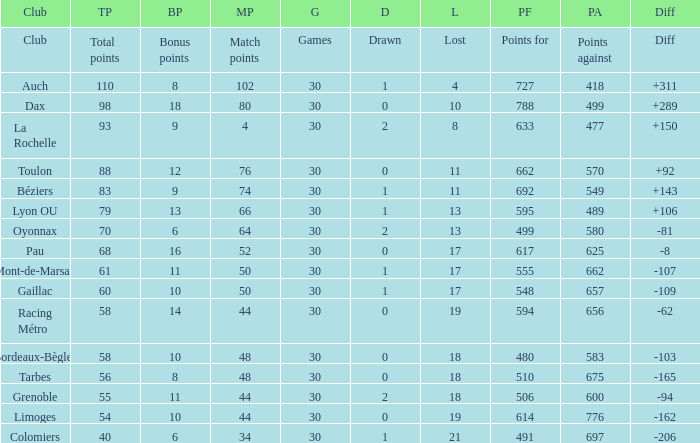What is the number of games for a club that has a value of 595 for points for? 30.0. 